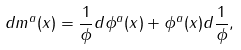<formula> <loc_0><loc_0><loc_500><loc_500>d m ^ { a } ( x ) = \frac { 1 } { \| \phi \| } d \phi ^ { a } ( x ) + \phi ^ { a } ( x ) d \frac { 1 } { \| \phi \| } ,</formula> 